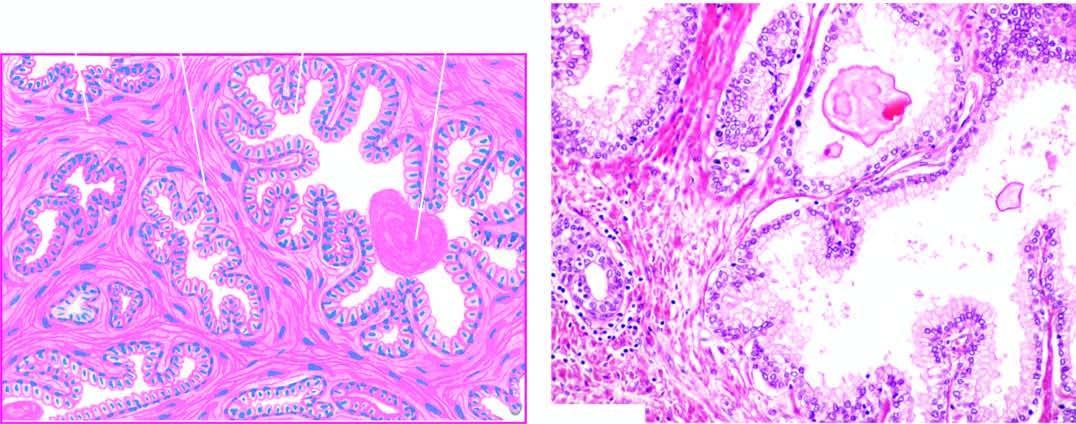s line of demarcation between gangrenous segment and the viable bowel hyperplasia of fibromuscular elements?
Answer the question using a single word or phrase. No 